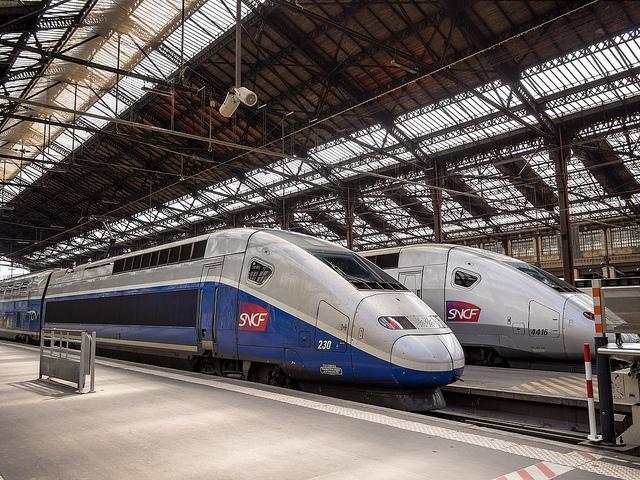How many trains are there?
Give a very brief answer. 2. 